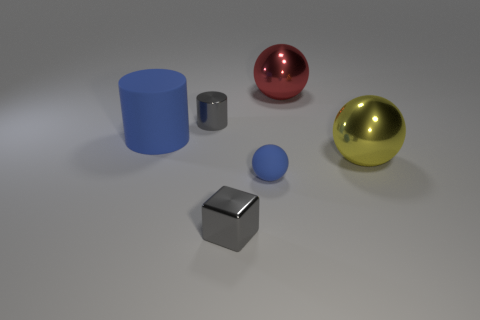Add 4 small metal cylinders. How many objects exist? 10 Subtract all cylinders. How many objects are left? 4 Add 4 red metallic things. How many red metallic things are left? 5 Add 4 blue cylinders. How many blue cylinders exist? 5 Subtract 0 red cylinders. How many objects are left? 6 Subtract all tiny blue objects. Subtract all large blue rubber cylinders. How many objects are left? 4 